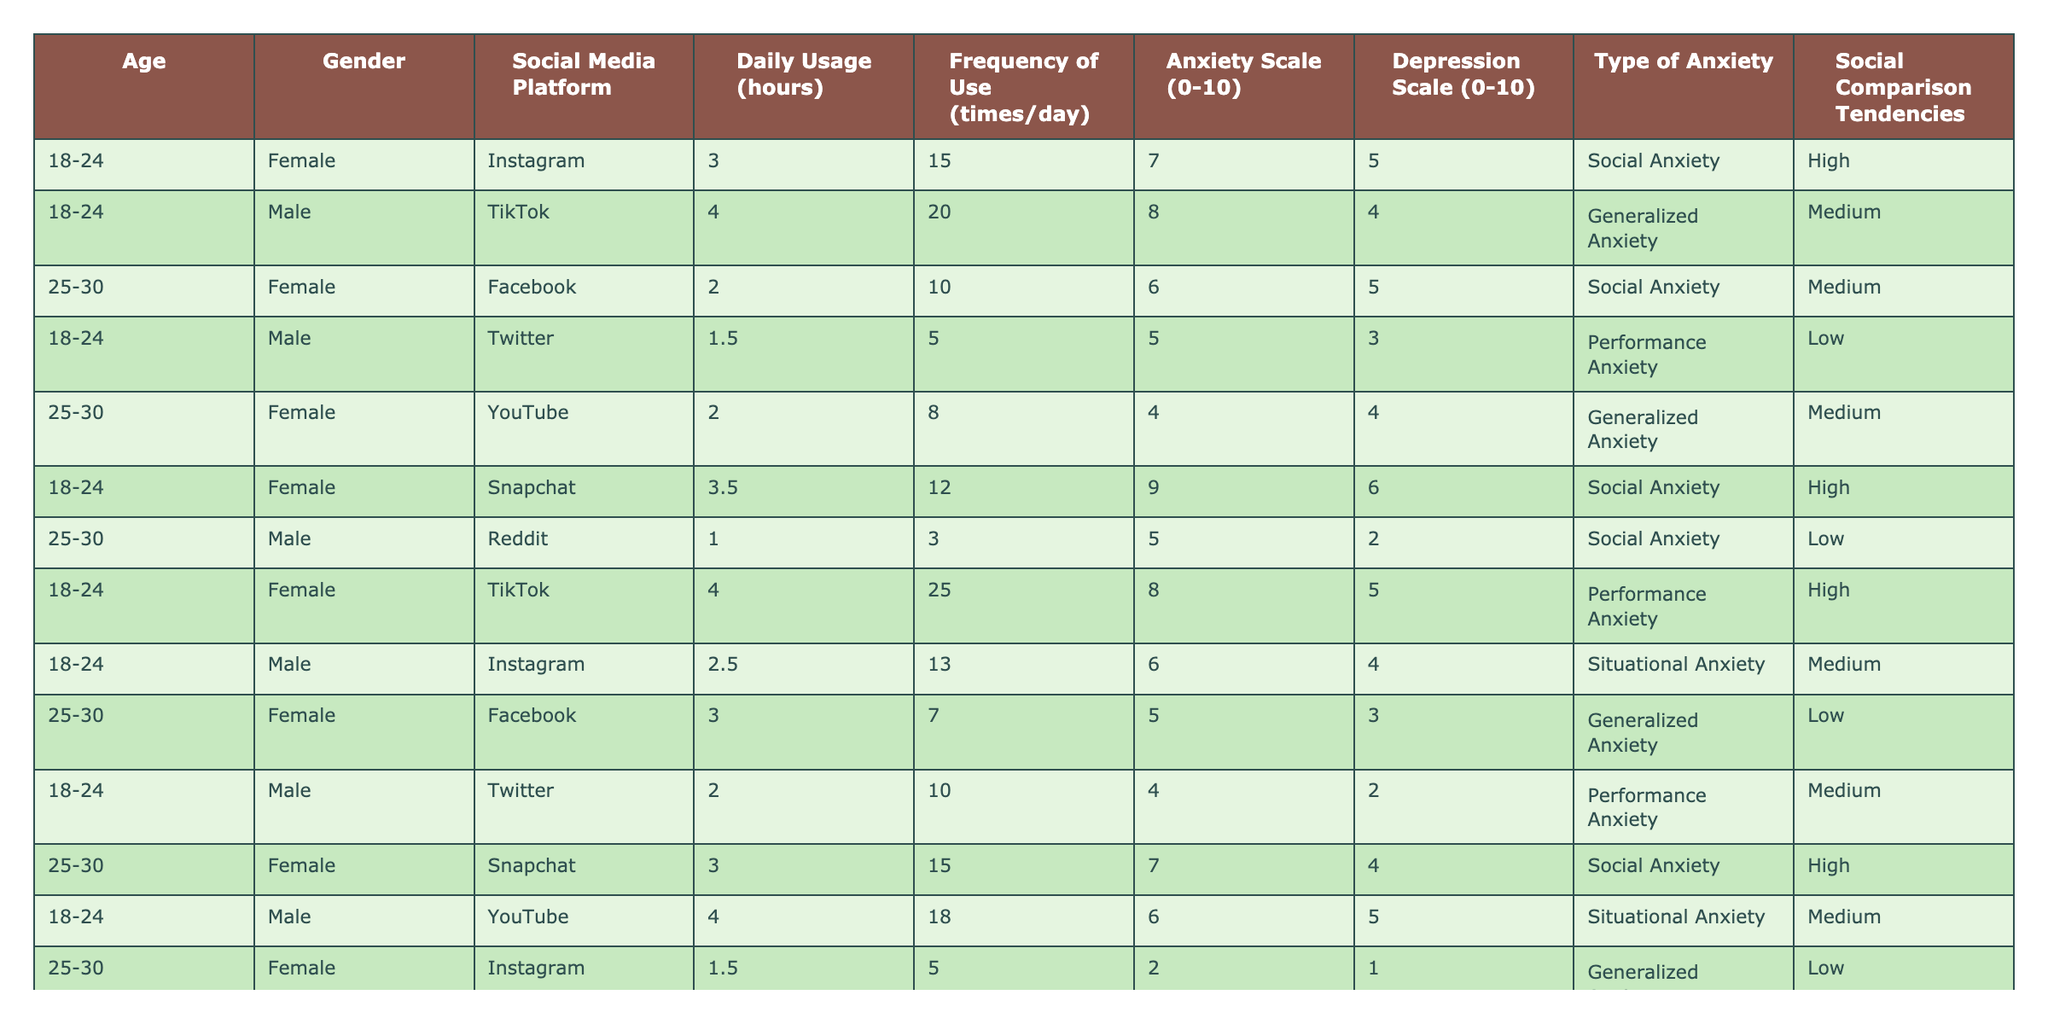What is the most frequently used social media platform among the respondents? Looking through the "Social Media Platform" column, Instagram appears 6 times, TikTok 5 times, Facebook and Snapchat each 4 times, YouTube 3 times, Twitter 3 times, and Reddit 2 times. Therefore, Instagram is the most frequently used platform.
Answer: Instagram What is the average anxiety scale score for users of TikTok? The anxiety scores for TikTok users are 8, 9, and 5. Adding them up gives 8 + 9 + 5 = 22. There are 3 TikTok users, so the average score is 22 / 3 = 7.33.
Answer: 7.33 Is there a user on Snapchat with a depression scale of 6 or more? Examining the depression scores for Snapchat users, we find scores of 6 for one user and 4 for another. Therefore, there is a user with a depression scale of 6 or more.
Answer: Yes What is the relationship between the daily usage hours and the anxiety scale score? Analyzing the users with high daily usage, those who use their platforms for 4 hours or more have anxiety scores of 8, 9, 8, 6, and 6, indicating a higher tendency for anxiety while high usage is correlated with higher anxiety scores. Meanwhile, those with lower usage (1 - 2 hours) have lower scores. A deeper analysis shows a positive correlation.
Answer: Positive correlation How many users exhibit high social comparison tendencies and have a social anxiety type? From the table, there are 3 users (Instagram and TikTok users) who show high social comparison tendencies alongside social anxiety.
Answer: 3 What is the difference in the average anxiety scale score between females and males? The average anxiety score for females is (7 + 6 + 4 + 9 + 5 + 2) / 6 = 5.5 and for males is (8 + 5 + 4 + 6 + 5) / 5 = 5.6. The difference is 5.6 - 5.5 = 0.1.
Answer: 0.1 Is there any user aged 25-30 with a performance anxiety type? Checking the data for age 25-30, we find no users listed with performance anxiety; they seem to be primarily associated with social anxiety and generalized anxiety types.
Answer: No What is the average daily usage of the platform for users with high anxiety scores? Users with high anxiety scores (7, 8, and 9) have daily usage hours of 3, 4, 3.5, and 4 which total to 14. The average for the 4 users is then 14 / 4 = 3.5 hours.
Answer: 3.5 hours Which social media platform has the highest average anxiety scale score? The anxiety scores for each social media platform are: Instagram (7.5), TikTok (8.5), Facebook (5.5), Twitter (4.5), YouTube (4), and Snapchat (8). The highest average is for TikTok users.
Answer: TikTok 